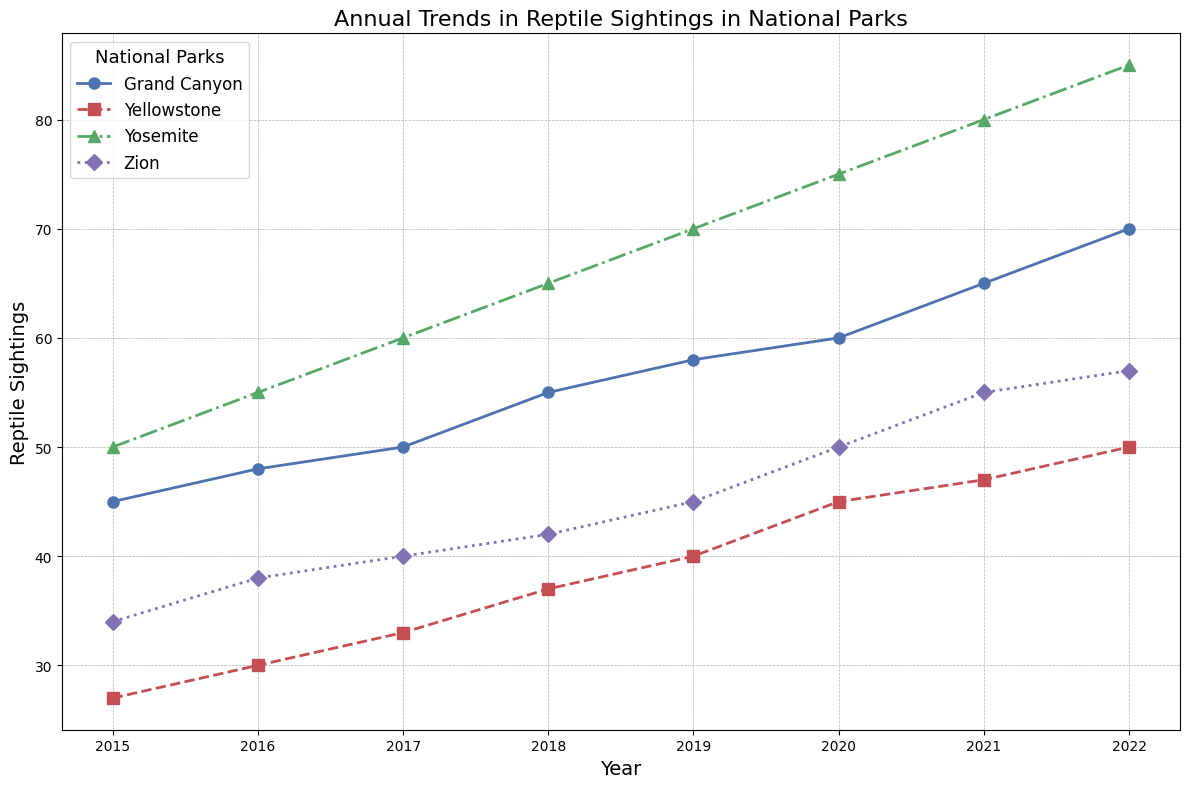How many reptile sightings were there at Yosemite and Yellowstone combined in 2022? First, find the reptile sightings at Yosemite in 2022, which is 85. Then, find the sightings at Yellowstone in 2022, which is 50. Add these two values together: 85 + 50 = 135.
Answer: 135 Which national park had the highest increase in reptile sightings from 2015 to 2022? Calculate the difference in reptile sightings between 2022 and 2015 for each park. Yosemite: 85 - 50 = 35, Zion: 57 - 34 = 23, Yellowstone: 50 - 27 = 23, Grand Canyon: 70 - 45 = 25. Yosemite has the highest increase of 35 sightings.
Answer: Yosemite What was the difference in reptile sightings between Zion and Grand Canyon in 2020? Look at the reptile sightings for Zion in 2020, which is 50, and Grand Canyon in 2020, which is 60. Subtract Zion's value from Grand Canyon's value: 60 - 50 = 10.
Answer: 10 Between 2019 and 2020, which national park had the smallest change in reptile sightings? Calculate the change in reptile sightings for each park from 2019 to 2020. Yosemite: 75 - 70 = 5, Zion: 50 - 45 = 5, Yellowstone: 45 - 40 = 5, Grand Canyon: 60 - 58 = 2. Grand Canyon has the smallest change of 2 sightings.
Answer: Grand Canyon In which year did Zion have its highest number of reptile sightings? Look for the highest value in Zion's sightings over the years: 34 in 2015, 38 in 2016, 40 in 2017, 42 in 2018, 45 in 2019, 50 in 2020, 55 in 2021, 57 in 2022. The highest number is 57 in 2022.
Answer: 2022 What is the average number of reptile sightings at Yellowstone over the entire period from 2015 to 2022? Sum the reptile sightings at Yellowstone from 2015 to 2022: 27 + 30 + 33 + 37 + 40 + 45 + 47 + 50 = 309. Divide by the number of years, which is 8: 309 / 8 = 38.625.
Answer: 38.625 Which park shows a consistent increase in reptile sightings every year from 2015 to 2022? Check each park's data year-by-year to see if the sightings increase every year: Yosemite (50, 55, 60, 65, 70, 75, 80, 85), Zion (34, 38, 40, 42, 45, 50, 55, 57), Yellowstone (27, 30, 33, 37, 40, 45, 47, 50), Grand Canyon (45, 48, 50, 55, 58, 60, 65, 70). Only Yosemite consistently increases each year.
Answer: Yosemite 